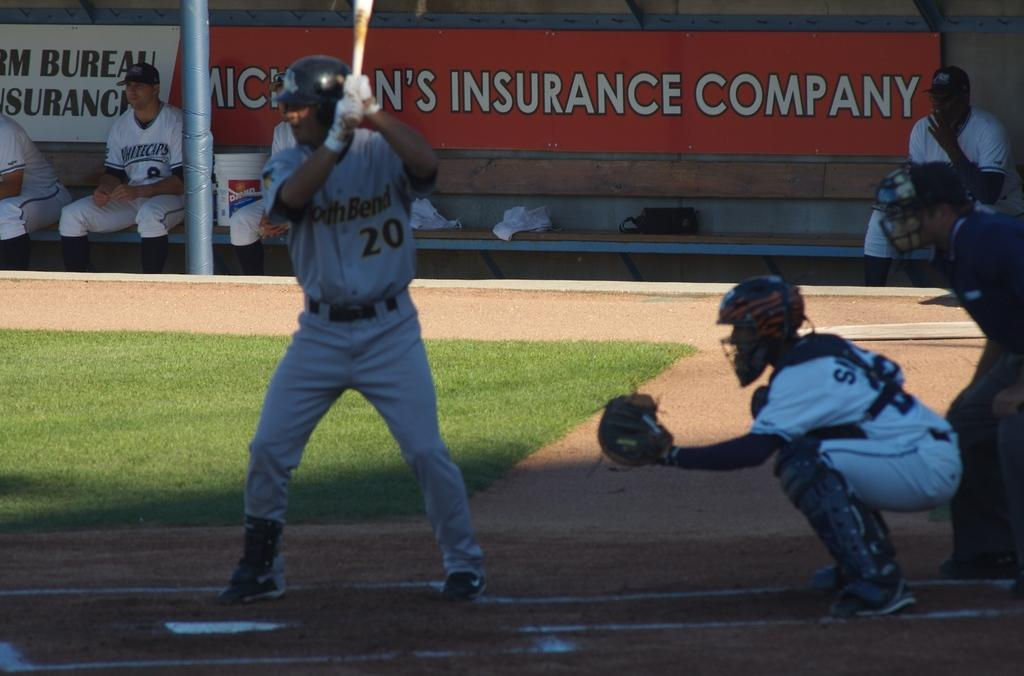<image>
Relay a brief, clear account of the picture shown. An insurance company is one of the sponsors of this sports team. 